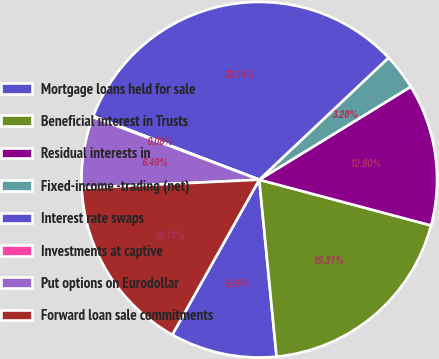<chart> <loc_0><loc_0><loc_500><loc_500><pie_chart><fcel>Mortgage loans held for sale<fcel>Beneficial interest in Trusts<fcel>Residual interests in<fcel>Fixed-income -trading (net)<fcel>Interest rate swaps<fcel>Investments at captive<fcel>Put options on Eurodollar<fcel>Forward loan sale commitments<nl><fcel>9.69%<fcel>19.31%<fcel>12.9%<fcel>3.28%<fcel>32.14%<fcel>0.08%<fcel>6.49%<fcel>16.11%<nl></chart> 